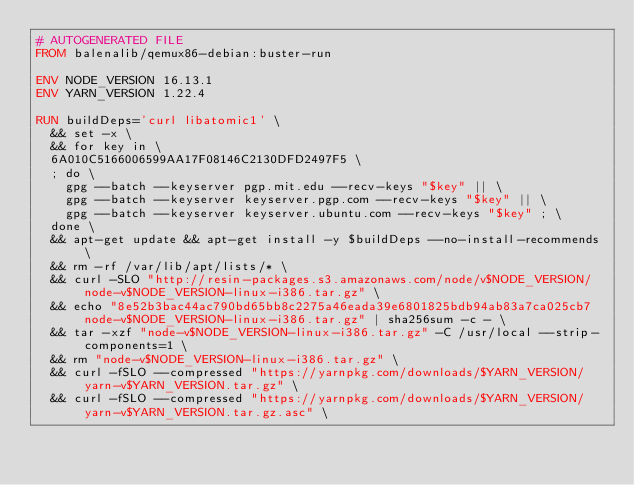<code> <loc_0><loc_0><loc_500><loc_500><_Dockerfile_># AUTOGENERATED FILE
FROM balenalib/qemux86-debian:buster-run

ENV NODE_VERSION 16.13.1
ENV YARN_VERSION 1.22.4

RUN buildDeps='curl libatomic1' \
	&& set -x \
	&& for key in \
	6A010C5166006599AA17F08146C2130DFD2497F5 \
	; do \
		gpg --batch --keyserver pgp.mit.edu --recv-keys "$key" || \
		gpg --batch --keyserver keyserver.pgp.com --recv-keys "$key" || \
		gpg --batch --keyserver keyserver.ubuntu.com --recv-keys "$key" ; \
	done \
	&& apt-get update && apt-get install -y $buildDeps --no-install-recommends \
	&& rm -rf /var/lib/apt/lists/* \
	&& curl -SLO "http://resin-packages.s3.amazonaws.com/node/v$NODE_VERSION/node-v$NODE_VERSION-linux-i386.tar.gz" \
	&& echo "8e52b3bac44ac790bd65bb8c2275a46eada39e6801825bdb94ab83a7ca025cb7  node-v$NODE_VERSION-linux-i386.tar.gz" | sha256sum -c - \
	&& tar -xzf "node-v$NODE_VERSION-linux-i386.tar.gz" -C /usr/local --strip-components=1 \
	&& rm "node-v$NODE_VERSION-linux-i386.tar.gz" \
	&& curl -fSLO --compressed "https://yarnpkg.com/downloads/$YARN_VERSION/yarn-v$YARN_VERSION.tar.gz" \
	&& curl -fSLO --compressed "https://yarnpkg.com/downloads/$YARN_VERSION/yarn-v$YARN_VERSION.tar.gz.asc" \</code> 